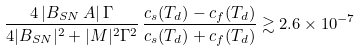<formula> <loc_0><loc_0><loc_500><loc_500>\frac { 4 \, | B _ { S N } \, A | \, \Gamma } { 4 | B _ { S N } | ^ { 2 } + | M | ^ { 2 } \Gamma ^ { 2 } } \, \frac { c _ { s } ( T _ { d } ) - c _ { f } ( T _ { d } ) } { c _ { s } ( T _ { d } ) + c _ { f } ( T _ { d } ) } \gtrsim 2 . 6 \times 1 0 ^ { - 7 }</formula> 